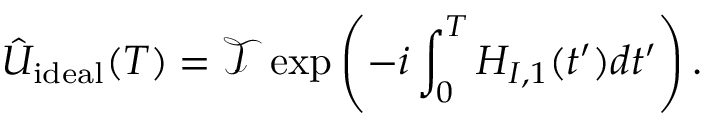<formula> <loc_0><loc_0><loc_500><loc_500>\hat { U } _ { i d e a l } ( T ) = \mathcal { T } \exp \left ( - i \int _ { 0 } ^ { T } H _ { I , 1 } ( t ^ { \prime } ) d t ^ { \prime } \right ) .</formula> 